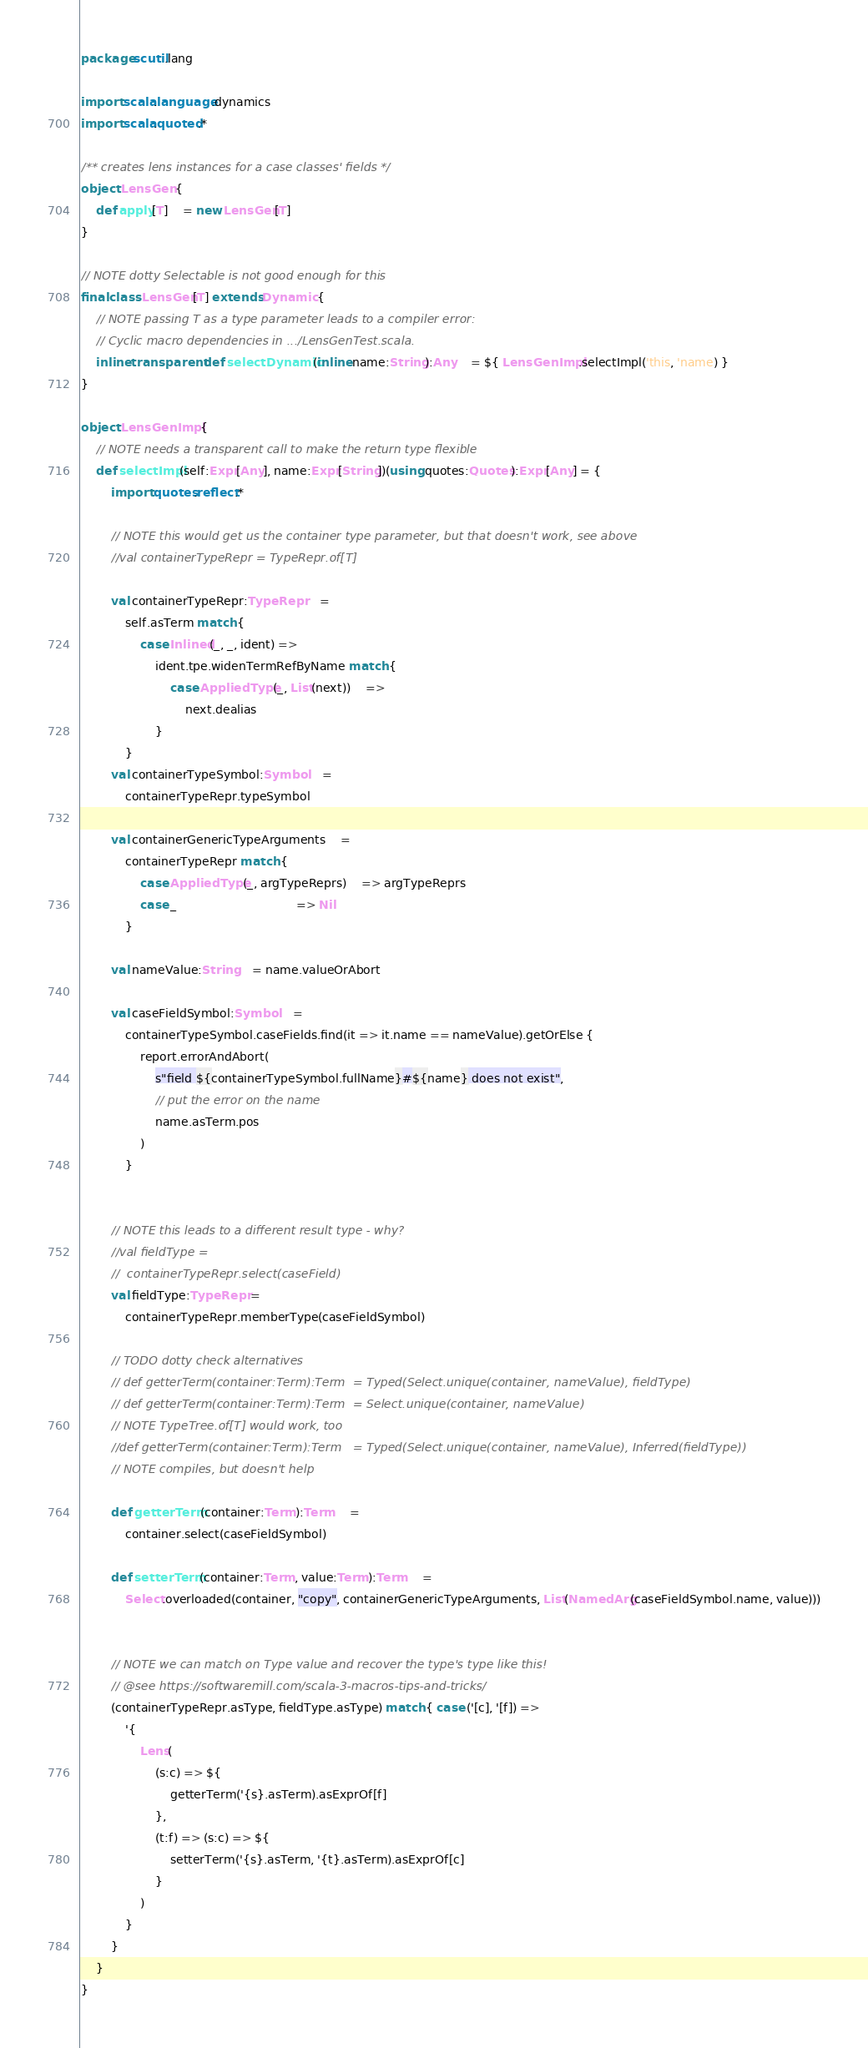<code> <loc_0><loc_0><loc_500><loc_500><_Scala_>package scutil.lang

import scala.language.dynamics
import scala.quoted.*

/** creates lens instances for a case classes' fields */
object LensGen {
	def apply[T]	= new LensGen[T]
}

// NOTE dotty Selectable is not good enough for this
final class LensGen[T] extends Dynamic {
	// NOTE passing T as a type parameter leads to a compiler error:
	// Cyclic macro dependencies in .../LensGenTest.scala.
	inline transparent def selectDynamic(inline name:String):Any	= ${ LensGenImpl.selectImpl('this, 'name) }
}

object LensGenImpl {
	// NOTE needs a transparent call to make the return type flexible
	def selectImpl(self:Expr[Any], name:Expr[String])(using quotes:Quotes):Expr[Any] = {
		import quotes.reflect.*

		// NOTE this would get us the container type parameter, but that doesn't work, see above
		//val containerTypeRepr	= TypeRepr.of[T]

		val containerTypeRepr:TypeRepr	=
			self.asTerm match {
				case Inlined(_, _, ident) =>
					ident.tpe.widenTermRefByName match {
						case AppliedType(_, List(next))	=>
							next.dealias
					}
			}
		val containerTypeSymbol:Symbol	=
			containerTypeRepr.typeSymbol

		val containerGenericTypeArguments	=
			containerTypeRepr match {
				case AppliedType(_, argTypeReprs)	=> argTypeReprs
				case _								=> Nil
			}

		val nameValue:String	= name.valueOrAbort

		val caseFieldSymbol:Symbol	=
			containerTypeSymbol.caseFields.find(it => it.name == nameValue).getOrElse {
				report.errorAndAbort(
					s"field ${containerTypeSymbol.fullName}#${name} does not exist",
					// put the error on the name
					name.asTerm.pos
				)
			}


		// NOTE this leads to a different result type - why?
		//val fieldType =
		//	containerTypeRepr.select(caseField)
		val fieldType:TypeRepr =
			containerTypeRepr.memberType(caseFieldSymbol)

		// TODO dotty check alternatives
		// def getterTerm(container:Term):Term	= Typed(Select.unique(container, nameValue), fieldType)
		// def getterTerm(container:Term):Term	= Select.unique(container, nameValue)
		// NOTE TypeTree.of[T] would work, too
		//def getterTerm(container:Term):Term	= Typed(Select.unique(container, nameValue), Inferred(fieldType))
		// NOTE compiles, but doesn't help

		def getterTerm(container:Term):Term	=
			container.select(caseFieldSymbol)

		def setterTerm(container:Term, value:Term):Term	=
		 	Select.overloaded(container, "copy", containerGenericTypeArguments, List(NamedArg(caseFieldSymbol.name, value)))


		// NOTE we can match on Type value and recover the type's type like this!
		// @see https://softwaremill.com/scala-3-macros-tips-and-tricks/
		(containerTypeRepr.asType, fieldType.asType) match { case ('[c], '[f]) =>
			'{
				Lens(
					(s:c) => ${
						getterTerm('{s}.asTerm).asExprOf[f]
					},
					(t:f) => (s:c) => ${
						setterTerm('{s}.asTerm, '{t}.asTerm).asExprOf[c]
					}
				)
			}
		}
	}
}
</code> 